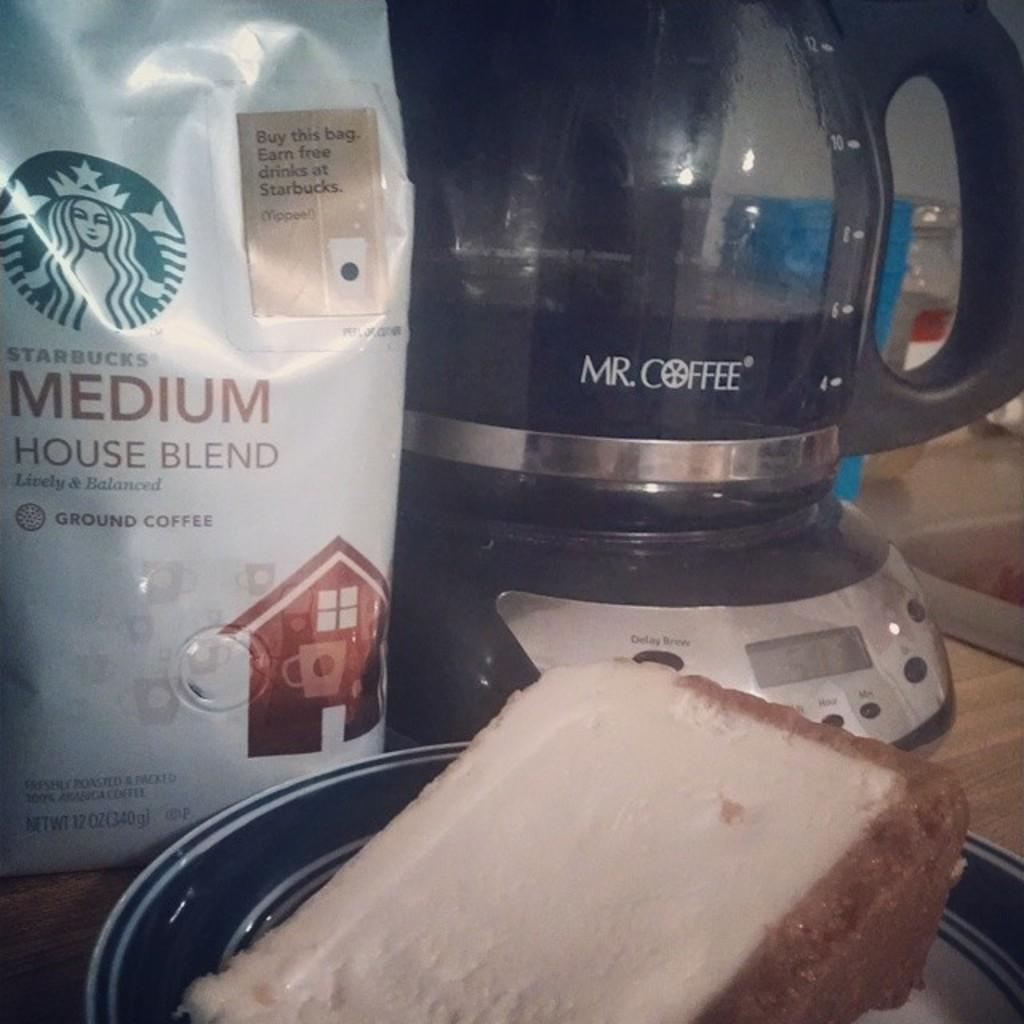<image>
Write a terse but informative summary of the picture. A bag of Starbucks Medium House Blend Coffee sits on the counter next to a coffee pot. 